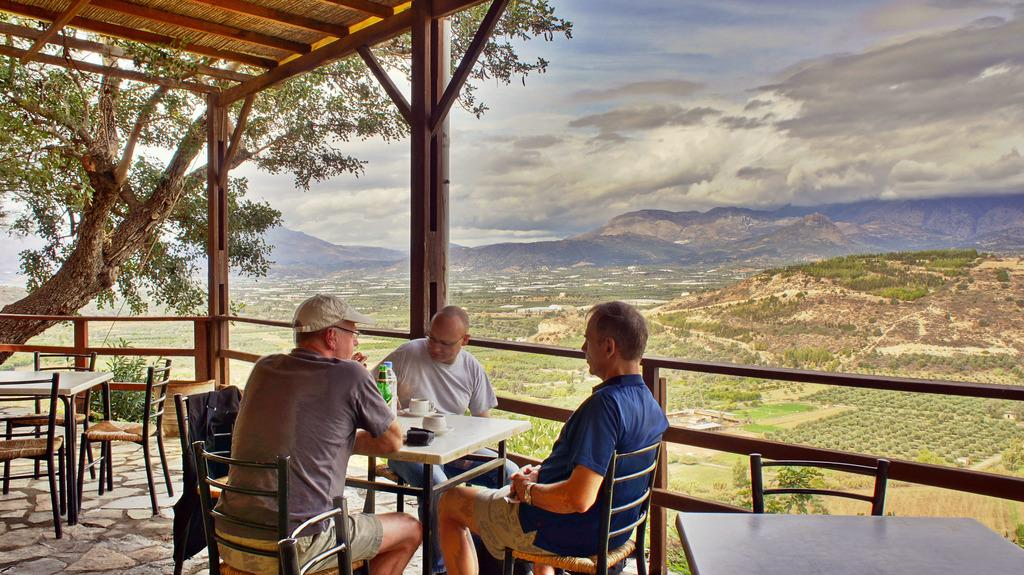How many people are sitting in the image? There are three people sitting in the image. What are the people sitting in front of? The people are sitting in front of a table. What can be seen on the table? There are cups and bottles on the table. What is visible in the background of the image? There are mountains, sky, and trees visible in the background of the image. What type of alarm is ringing in the image? There is no alarm present in the image. What treatment is being administered to the people in the image? There is no treatment being administered to the people in the image; they are simply sitting in front of a table. 